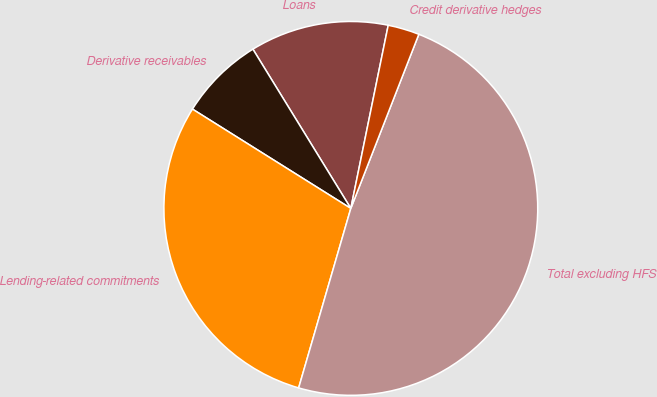<chart> <loc_0><loc_0><loc_500><loc_500><pie_chart><fcel>Loans<fcel>Derivative receivables<fcel>Lending-related commitments<fcel>Total excluding HFS<fcel>Credit derivative hedges<nl><fcel>11.98%<fcel>7.31%<fcel>29.41%<fcel>48.57%<fcel>2.72%<nl></chart> 